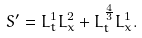<formula> <loc_0><loc_0><loc_500><loc_500>S ^ { \prime } = L ^ { 1 } _ { t } L ^ { 2 } _ { x } + L ^ { \frac { 4 } { 3 } } _ { t } L ^ { 1 } _ { x } .</formula> 